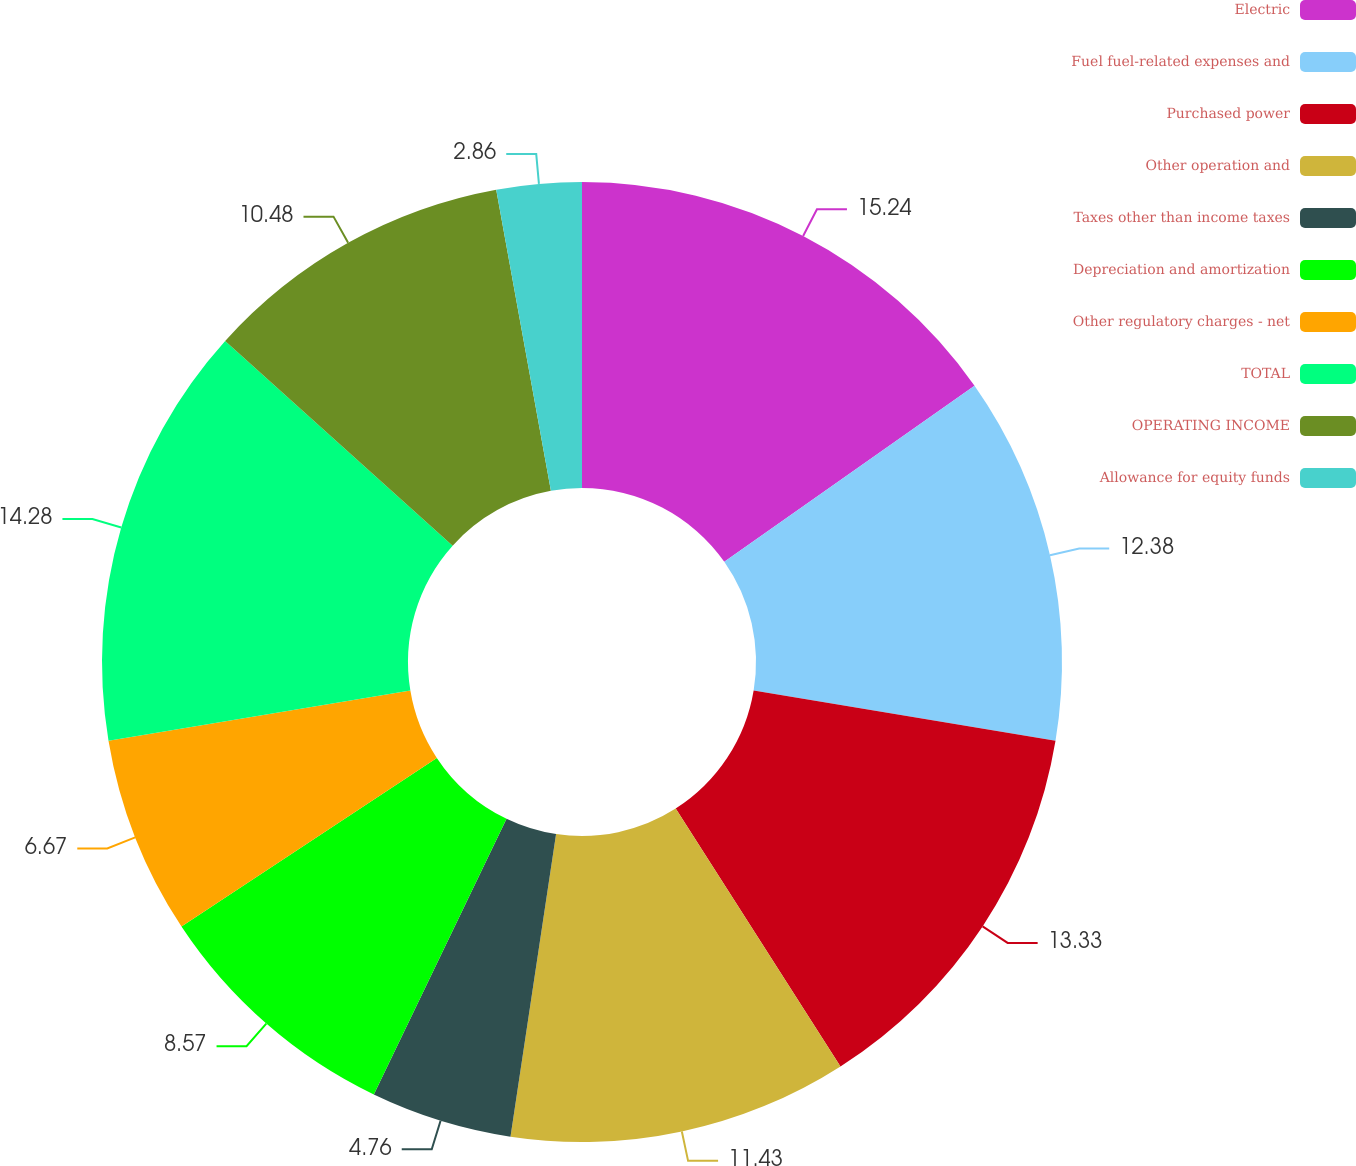<chart> <loc_0><loc_0><loc_500><loc_500><pie_chart><fcel>Electric<fcel>Fuel fuel-related expenses and<fcel>Purchased power<fcel>Other operation and<fcel>Taxes other than income taxes<fcel>Depreciation and amortization<fcel>Other regulatory charges - net<fcel>TOTAL<fcel>OPERATING INCOME<fcel>Allowance for equity funds<nl><fcel>15.24%<fcel>12.38%<fcel>13.33%<fcel>11.43%<fcel>4.76%<fcel>8.57%<fcel>6.67%<fcel>14.28%<fcel>10.48%<fcel>2.86%<nl></chart> 